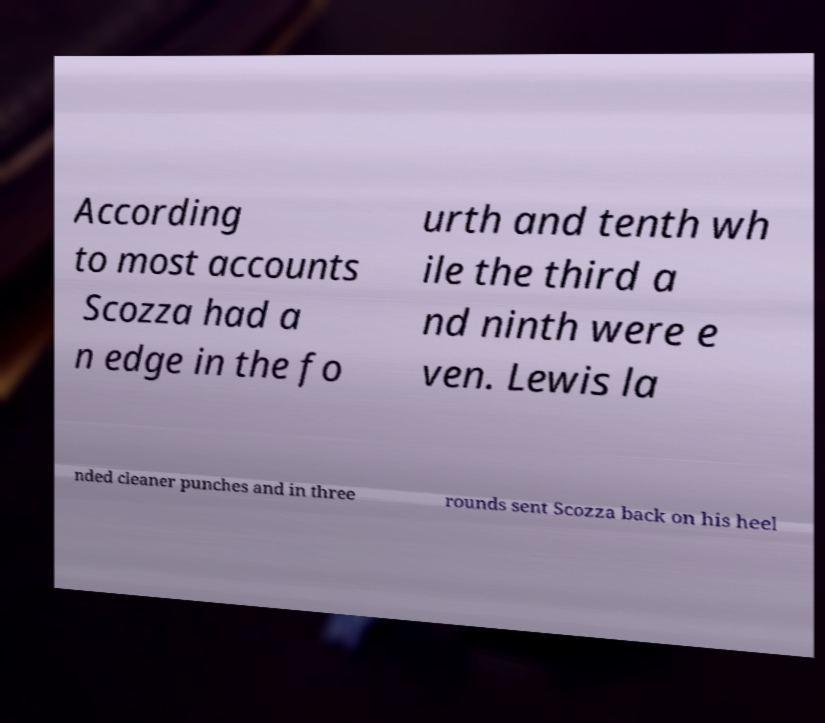For documentation purposes, I need the text within this image transcribed. Could you provide that? According to most accounts Scozza had a n edge in the fo urth and tenth wh ile the third a nd ninth were e ven. Lewis la nded cleaner punches and in three rounds sent Scozza back on his heel 